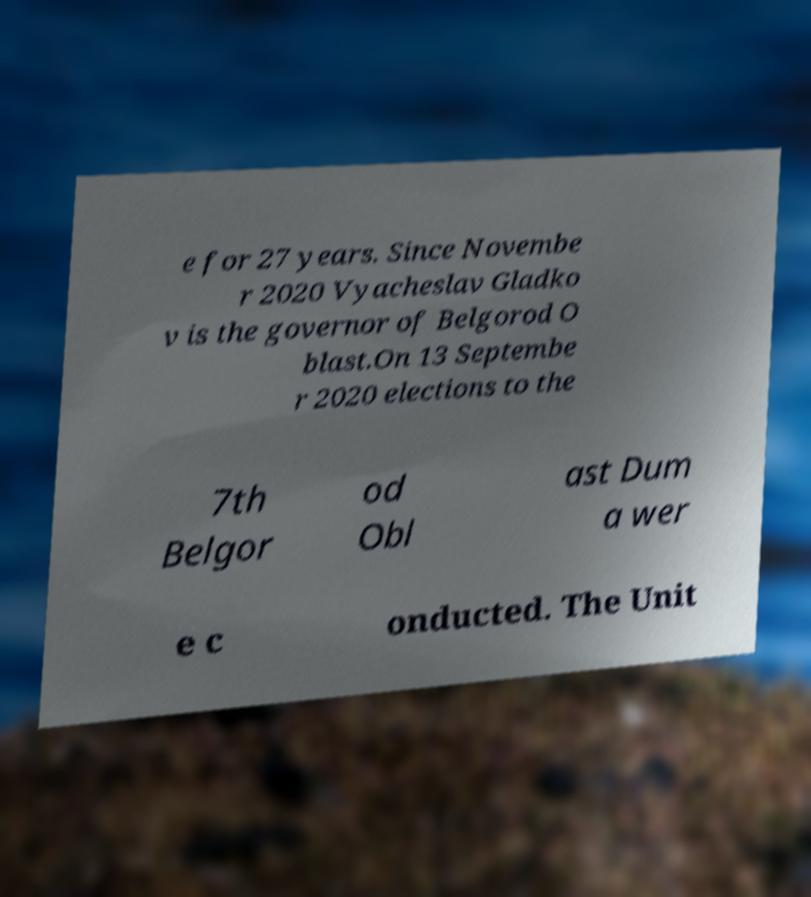I need the written content from this picture converted into text. Can you do that? e for 27 years. Since Novembe r 2020 Vyacheslav Gladko v is the governor of Belgorod O blast.On 13 Septembe r 2020 elections to the 7th Belgor od Obl ast Dum a wer e c onducted. The Unit 